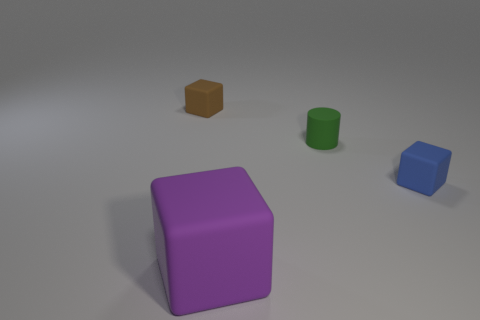Is there anything else that has the same size as the brown object?
Provide a succinct answer. Yes. How many small blocks are the same color as the big rubber cube?
Your answer should be very brief. 0. There is a tiny cylinder; is it the same color as the cube in front of the small blue matte block?
Give a very brief answer. No. What number of things are matte cylinders or cubes behind the large purple thing?
Make the answer very short. 3. There is a brown rubber object behind the small matte block to the right of the small green cylinder; what is its size?
Offer a terse response. Small. Are there an equal number of rubber cubes in front of the blue thing and matte objects that are on the right side of the large purple rubber block?
Your response must be concise. No. There is a small brown rubber thing left of the small green matte thing; is there a large purple matte block that is left of it?
Make the answer very short. No. What is the shape of the green object that is the same material as the large purple block?
Offer a terse response. Cylinder. Are there any other things that are the same color as the large rubber cube?
Your answer should be compact. No. What material is the tiny block on the right side of the block to the left of the large purple thing?
Your response must be concise. Rubber. 